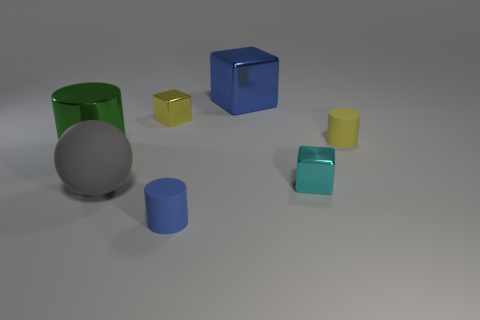Add 1 big green cylinders. How many objects exist? 8 Subtract all cylinders. How many objects are left? 4 Subtract all green metallic things. Subtract all yellow metal objects. How many objects are left? 5 Add 5 gray matte balls. How many gray matte balls are left? 6 Add 6 red metal spheres. How many red metal spheres exist? 6 Subtract 1 cyan cubes. How many objects are left? 6 